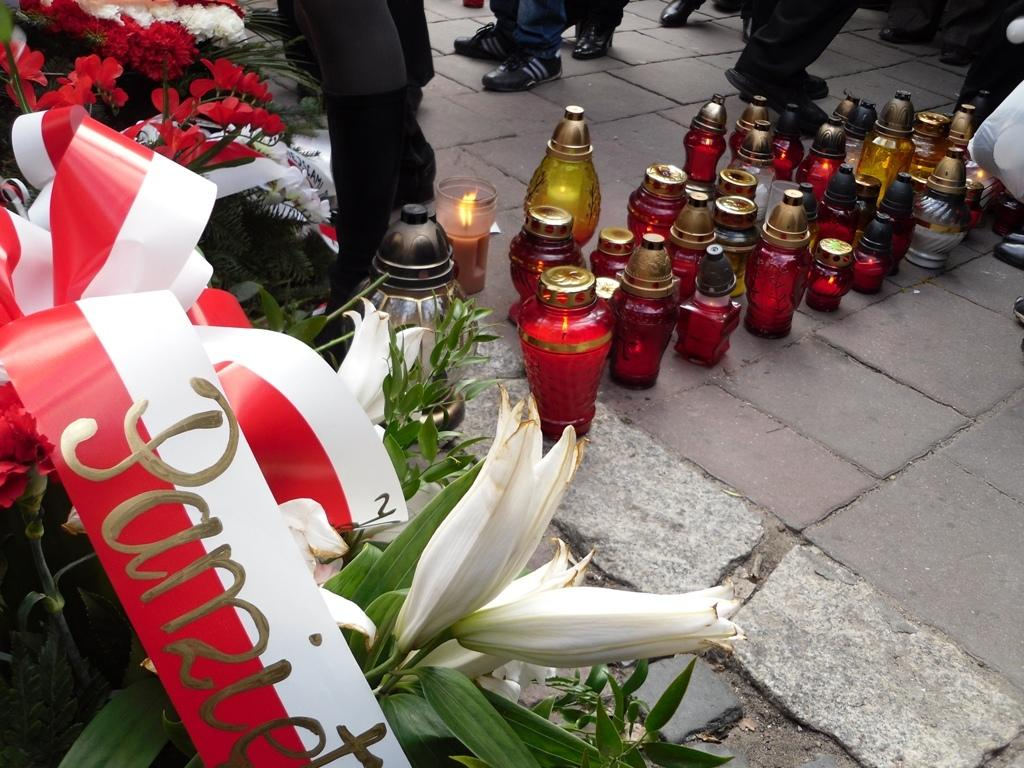What type of living organisms can be seen in the image? Plants can be seen in the image. What is attached to or associated with the plants? There is a ribbon associated with the plants. What type of containers are present on the ground? Bottles and jars are present on the ground. Can you describe the background of the image? There are many people standing in the background of the image. What type of grain is being harvested by the cats in the image? There are no cats present in the image, and therefore no grain harvesting can be observed. 